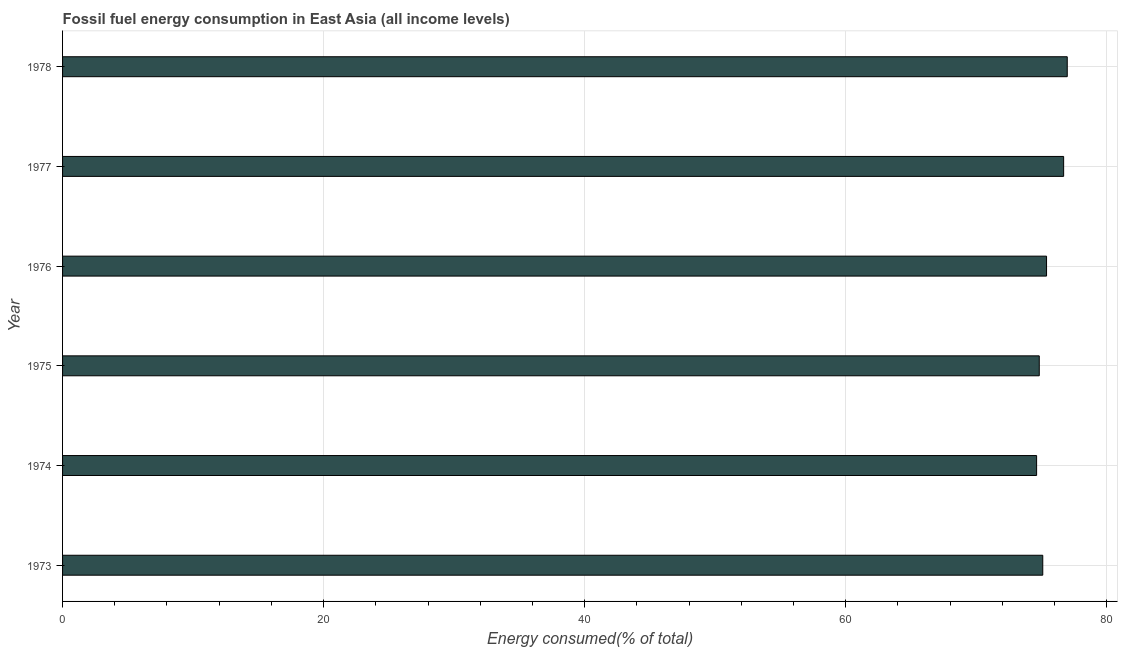What is the title of the graph?
Provide a short and direct response. Fossil fuel energy consumption in East Asia (all income levels). What is the label or title of the X-axis?
Give a very brief answer. Energy consumed(% of total). What is the label or title of the Y-axis?
Give a very brief answer. Year. What is the fossil fuel energy consumption in 1974?
Your answer should be very brief. 74.63. Across all years, what is the maximum fossil fuel energy consumption?
Offer a very short reply. 76.98. Across all years, what is the minimum fossil fuel energy consumption?
Make the answer very short. 74.63. In which year was the fossil fuel energy consumption maximum?
Give a very brief answer. 1978. In which year was the fossil fuel energy consumption minimum?
Provide a succinct answer. 1974. What is the sum of the fossil fuel energy consumption?
Your answer should be very brief. 453.65. What is the difference between the fossil fuel energy consumption in 1977 and 1978?
Give a very brief answer. -0.28. What is the average fossil fuel energy consumption per year?
Offer a very short reply. 75.61. What is the median fossil fuel energy consumption?
Keep it short and to the point. 75.25. In how many years, is the fossil fuel energy consumption greater than 4 %?
Your answer should be very brief. 6. What is the ratio of the fossil fuel energy consumption in 1977 to that in 1978?
Your response must be concise. 1. Is the fossil fuel energy consumption in 1974 less than that in 1977?
Offer a terse response. Yes. What is the difference between the highest and the second highest fossil fuel energy consumption?
Give a very brief answer. 0.28. What is the difference between the highest and the lowest fossil fuel energy consumption?
Your answer should be very brief. 2.35. How many years are there in the graph?
Provide a short and direct response. 6. Are the values on the major ticks of X-axis written in scientific E-notation?
Give a very brief answer. No. What is the Energy consumed(% of total) in 1973?
Ensure brevity in your answer.  75.1. What is the Energy consumed(% of total) in 1974?
Offer a very short reply. 74.63. What is the Energy consumed(% of total) in 1975?
Ensure brevity in your answer.  74.84. What is the Energy consumed(% of total) of 1976?
Ensure brevity in your answer.  75.39. What is the Energy consumed(% of total) in 1977?
Offer a very short reply. 76.7. What is the Energy consumed(% of total) of 1978?
Give a very brief answer. 76.98. What is the difference between the Energy consumed(% of total) in 1973 and 1974?
Offer a terse response. 0.47. What is the difference between the Energy consumed(% of total) in 1973 and 1975?
Ensure brevity in your answer.  0.27. What is the difference between the Energy consumed(% of total) in 1973 and 1976?
Ensure brevity in your answer.  -0.29. What is the difference between the Energy consumed(% of total) in 1973 and 1977?
Your answer should be very brief. -1.6. What is the difference between the Energy consumed(% of total) in 1973 and 1978?
Keep it short and to the point. -1.88. What is the difference between the Energy consumed(% of total) in 1974 and 1975?
Provide a short and direct response. -0.2. What is the difference between the Energy consumed(% of total) in 1974 and 1976?
Your response must be concise. -0.76. What is the difference between the Energy consumed(% of total) in 1974 and 1977?
Your answer should be compact. -2.07. What is the difference between the Energy consumed(% of total) in 1974 and 1978?
Ensure brevity in your answer.  -2.35. What is the difference between the Energy consumed(% of total) in 1975 and 1976?
Your answer should be compact. -0.56. What is the difference between the Energy consumed(% of total) in 1975 and 1977?
Ensure brevity in your answer.  -1.87. What is the difference between the Energy consumed(% of total) in 1975 and 1978?
Offer a terse response. -2.14. What is the difference between the Energy consumed(% of total) in 1976 and 1977?
Ensure brevity in your answer.  -1.31. What is the difference between the Energy consumed(% of total) in 1976 and 1978?
Keep it short and to the point. -1.59. What is the difference between the Energy consumed(% of total) in 1977 and 1978?
Your answer should be compact. -0.28. What is the ratio of the Energy consumed(% of total) in 1973 to that in 1975?
Provide a short and direct response. 1. What is the ratio of the Energy consumed(% of total) in 1973 to that in 1976?
Your answer should be compact. 1. What is the ratio of the Energy consumed(% of total) in 1973 to that in 1977?
Your answer should be very brief. 0.98. What is the ratio of the Energy consumed(% of total) in 1973 to that in 1978?
Your answer should be very brief. 0.98. What is the ratio of the Energy consumed(% of total) in 1974 to that in 1978?
Your response must be concise. 0.97. What is the ratio of the Energy consumed(% of total) in 1975 to that in 1976?
Make the answer very short. 0.99. What is the ratio of the Energy consumed(% of total) in 1975 to that in 1977?
Your answer should be very brief. 0.98. What is the ratio of the Energy consumed(% of total) in 1975 to that in 1978?
Your answer should be compact. 0.97. 